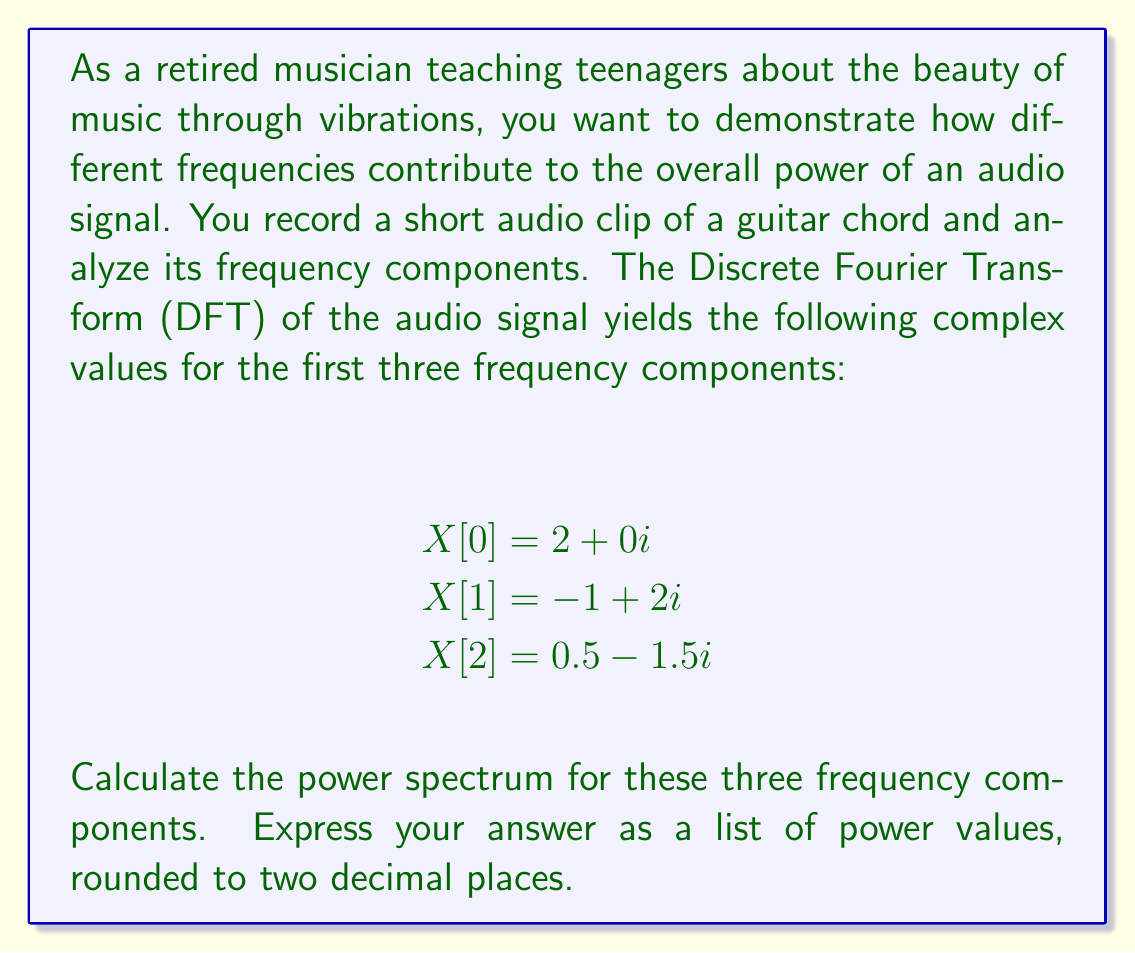Can you solve this math problem? To compute the power spectrum of an audio signal using complex conjugates, we follow these steps:

1) The power spectrum $P[k]$ for each frequency component $k$ is given by:

   $P[k] = X[k] \cdot X^*[k]$

   where $X[k]$ is the complex value of the DFT at frequency $k$, and $X^*[k]$ is its complex conjugate.

2) For a complex number $a + bi$, its complex conjugate is $a - bi$.

3) Let's calculate the power for each component:

   For $X[0] = 2 + 0i$:
   $P[0] = (2 + 0i)(2 - 0i) = 2^2 + 0^2 = 4$

   For $X[1] = -1 + 2i$:
   $P[1] = (-1 + 2i)(-1 - 2i) = (-1)^2 + 2^2 = 1 + 4 = 5$

   For $X[2] = 0.5 - 1.5i$:
   $P[2] = (0.5 - 1.5i)(0.5 + 1.5i) = 0.5^2 + 1.5^2 = 0.25 + 2.25 = 2.5$

4) Rounding each value to two decimal places:
   $P[0] = 4.00$
   $P[1] = 5.00$
   $P[2] = 2.50$

The power spectrum shows the contribution of each frequency component to the overall power of the signal. In this case, the second frequency component (index 1) has the highest power, indicating it's the most dominant in the audio signal.
Answer: [4.00, 5.00, 2.50] 